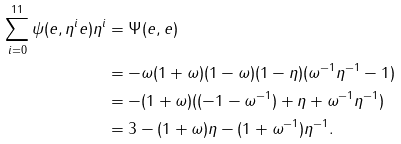<formula> <loc_0><loc_0><loc_500><loc_500>\sum _ { i = 0 } ^ { 1 1 } \psi ( e , \eta ^ { i } e ) \eta ^ { i } & = \Psi ( e , e ) \\ & = - \omega ( 1 + \omega ) ( 1 - \omega ) ( 1 - \eta ) ( \omega ^ { - 1 } \eta ^ { - 1 } - 1 ) \\ & = - ( 1 + \omega ) ( ( - 1 - \omega ^ { - 1 } ) + \eta + \omega ^ { - 1 } \eta ^ { - 1 } ) \\ & = 3 - ( 1 + \omega ) \eta - ( 1 + \omega ^ { - 1 } ) \eta ^ { - 1 } .</formula> 